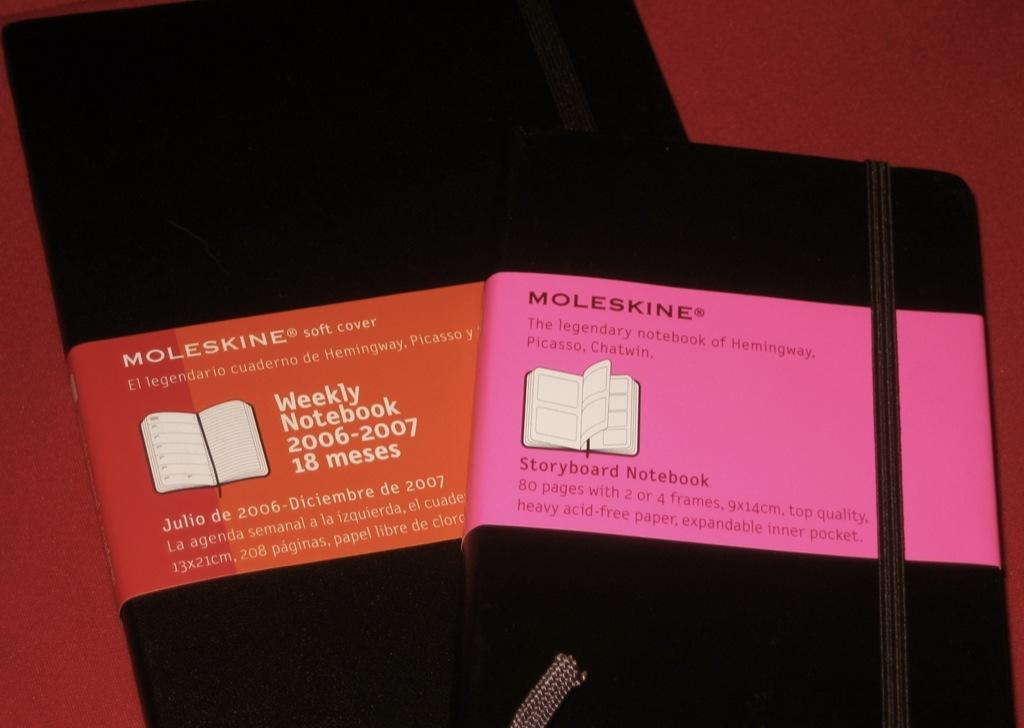<image>
Relay a brief, clear account of the picture shown. a pink square item with Moleskine on it 